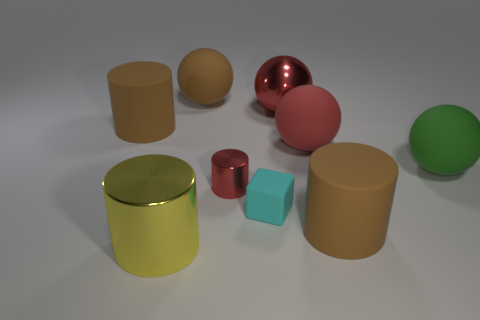There is a matte sphere that is on the left side of the tiny rubber block on the right side of the brown matte sphere; what is its size?
Provide a short and direct response. Large. Is the number of brown shiny balls greater than the number of matte balls?
Keep it short and to the point. No. There is a brown matte object that is in front of the green rubber object; is its size the same as the large red matte object?
Ensure brevity in your answer.  Yes. What number of blocks have the same color as the big metallic cylinder?
Provide a succinct answer. 0. Do the yellow metal thing and the cyan object have the same shape?
Keep it short and to the point. No. Is there anything else that is the same size as the yellow metal cylinder?
Keep it short and to the point. Yes. What size is the other red thing that is the same shape as the large red metallic object?
Your answer should be very brief. Large. Are there more small shiny cylinders behind the large red rubber sphere than cyan objects behind the small rubber cube?
Your response must be concise. No. Does the small cylinder have the same material as the large brown object that is left of the big brown matte ball?
Your response must be concise. No. Is there any other thing that has the same shape as the yellow thing?
Your response must be concise. Yes. 